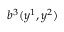Convert formula to latex. <formula><loc_0><loc_0><loc_500><loc_500>b ^ { 3 } ( y ^ { 1 } , y ^ { 2 } )</formula> 